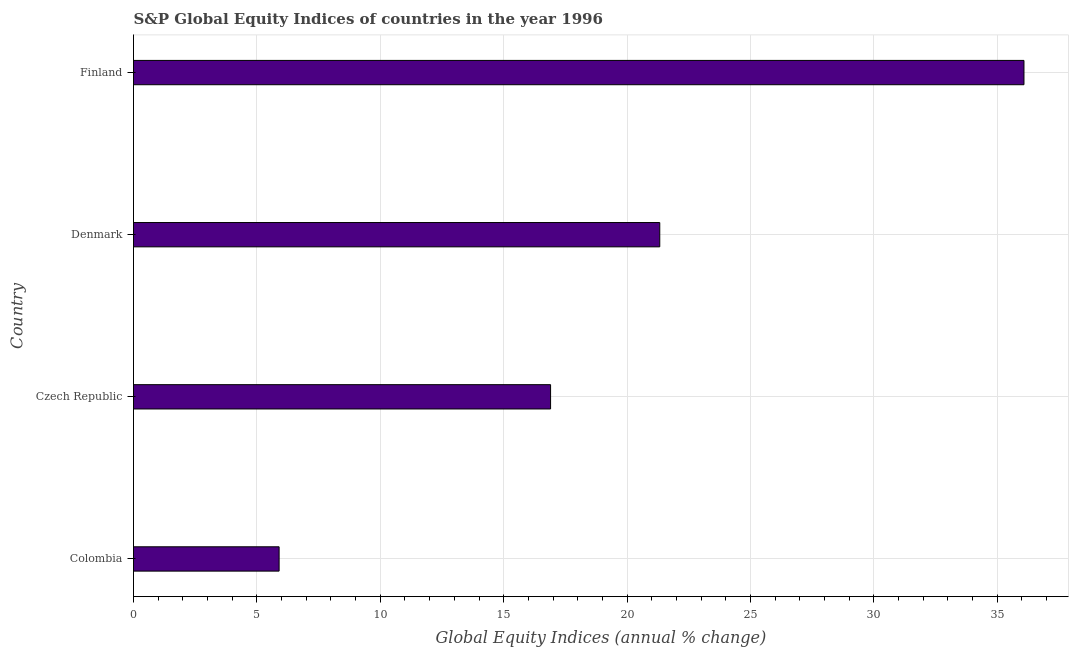Does the graph contain any zero values?
Make the answer very short. No. What is the title of the graph?
Your response must be concise. S&P Global Equity Indices of countries in the year 1996. What is the label or title of the X-axis?
Your answer should be very brief. Global Equity Indices (annual % change). What is the s&p global equity indices in Colombia?
Your answer should be very brief. 5.9. Across all countries, what is the maximum s&p global equity indices?
Offer a very short reply. 36.08. Across all countries, what is the minimum s&p global equity indices?
Provide a succinct answer. 5.9. What is the sum of the s&p global equity indices?
Your response must be concise. 80.21. What is the difference between the s&p global equity indices in Colombia and Finland?
Provide a short and direct response. -30.18. What is the average s&p global equity indices per country?
Make the answer very short. 20.05. What is the median s&p global equity indices?
Make the answer very short. 19.11. What is the ratio of the s&p global equity indices in Colombia to that in Finland?
Make the answer very short. 0.16. What is the difference between the highest and the second highest s&p global equity indices?
Provide a short and direct response. 14.76. What is the difference between the highest and the lowest s&p global equity indices?
Provide a short and direct response. 30.18. How many bars are there?
Offer a terse response. 4. How many countries are there in the graph?
Your response must be concise. 4. What is the difference between two consecutive major ticks on the X-axis?
Give a very brief answer. 5. Are the values on the major ticks of X-axis written in scientific E-notation?
Keep it short and to the point. No. What is the Global Equity Indices (annual % change) of Colombia?
Provide a succinct answer. 5.9. What is the Global Equity Indices (annual % change) of Czech Republic?
Your answer should be compact. 16.9. What is the Global Equity Indices (annual % change) in Denmark?
Your answer should be compact. 21.32. What is the Global Equity Indices (annual % change) of Finland?
Your response must be concise. 36.08. What is the difference between the Global Equity Indices (annual % change) in Colombia and Denmark?
Provide a short and direct response. -15.42. What is the difference between the Global Equity Indices (annual % change) in Colombia and Finland?
Give a very brief answer. -30.18. What is the difference between the Global Equity Indices (annual % change) in Czech Republic and Denmark?
Provide a succinct answer. -4.42. What is the difference between the Global Equity Indices (annual % change) in Czech Republic and Finland?
Your response must be concise. -19.18. What is the difference between the Global Equity Indices (annual % change) in Denmark and Finland?
Provide a short and direct response. -14.76. What is the ratio of the Global Equity Indices (annual % change) in Colombia to that in Czech Republic?
Offer a very short reply. 0.35. What is the ratio of the Global Equity Indices (annual % change) in Colombia to that in Denmark?
Ensure brevity in your answer.  0.28. What is the ratio of the Global Equity Indices (annual % change) in Colombia to that in Finland?
Your response must be concise. 0.16. What is the ratio of the Global Equity Indices (annual % change) in Czech Republic to that in Denmark?
Provide a short and direct response. 0.79. What is the ratio of the Global Equity Indices (annual % change) in Czech Republic to that in Finland?
Keep it short and to the point. 0.47. What is the ratio of the Global Equity Indices (annual % change) in Denmark to that in Finland?
Provide a short and direct response. 0.59. 